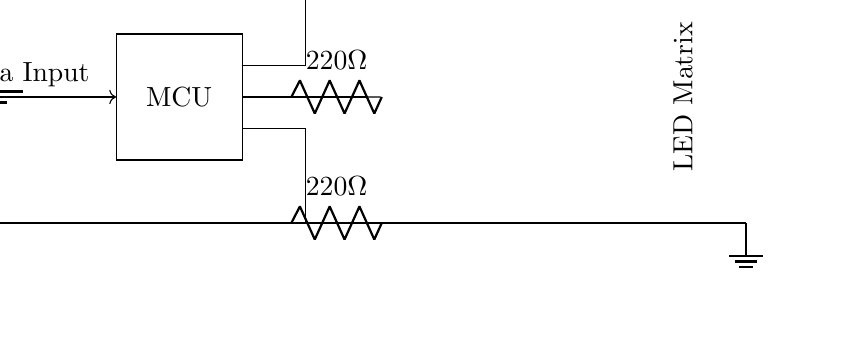What is the voltage supplied in the circuit? The voltage supplied in the circuit is 5 volts, which can be observed from the battery symbol indicating a 5V power source.
Answer: 5 volts What type of input does the microcontroller receive? The input type for the microcontroller is data input, which is indicated by the arrow pointing toward the MCU component labeled "Data Input."
Answer: Data Input How many resistors are present in the circuit? There are three resistors in the circuit, each connected to the LED matrix for current limiting. This is evident from the resistor symbols drawn next to the LEDs.
Answer: Three What components make up the LED array in the circuit? The LED array consists of nine individual LEDs arranged in a 3x3 grid pattern, as indicated by the repeated LED symbols grouped together.
Answer: Nine LEDs What is the resistance value of each resistor in the circuit? Each resistor in the circuit has a resistance value of 220 ohms, which is noted next to each resistor symbol in the diagram.
Answer: 220 ohms How is the ground connected in this circuit? The ground is connected along the bottom horizontal line of the circuit, where the ground symbol is indicated, linking to multiple components above.
Answer: Bottom horizontal line What is the primary function of the microcontroller in this circuit? The primary function of the microcontroller is to control the LED matrix by processing and displaying data for real-time game updates based on the input it receives.
Answer: Control LED matrix 